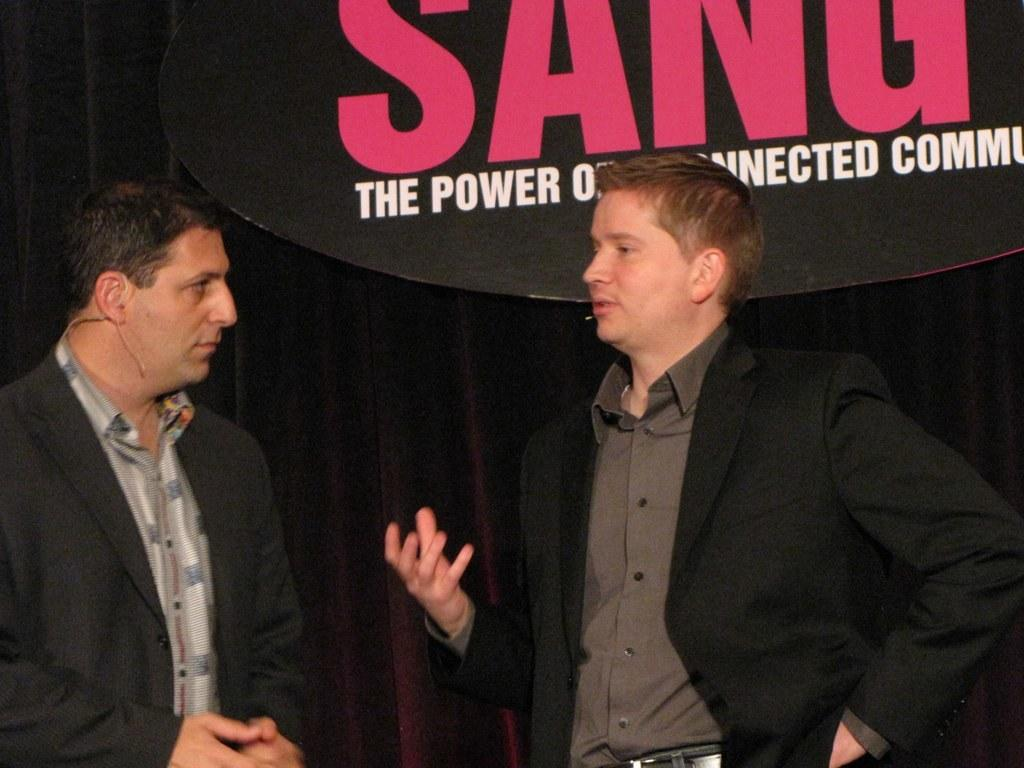What is present in the image that can be used for covering or blocking light? There is a curtain in the image. What surface are the men standing on in the image? The men are standing on the floor in the image. What type of punishment is being administered to the men in the image? There is no indication of punishment in the image; it only shows men standing on the floor and a curtain. What kind of farm animals can be seen in the image? There are no farm animals present in the image. 